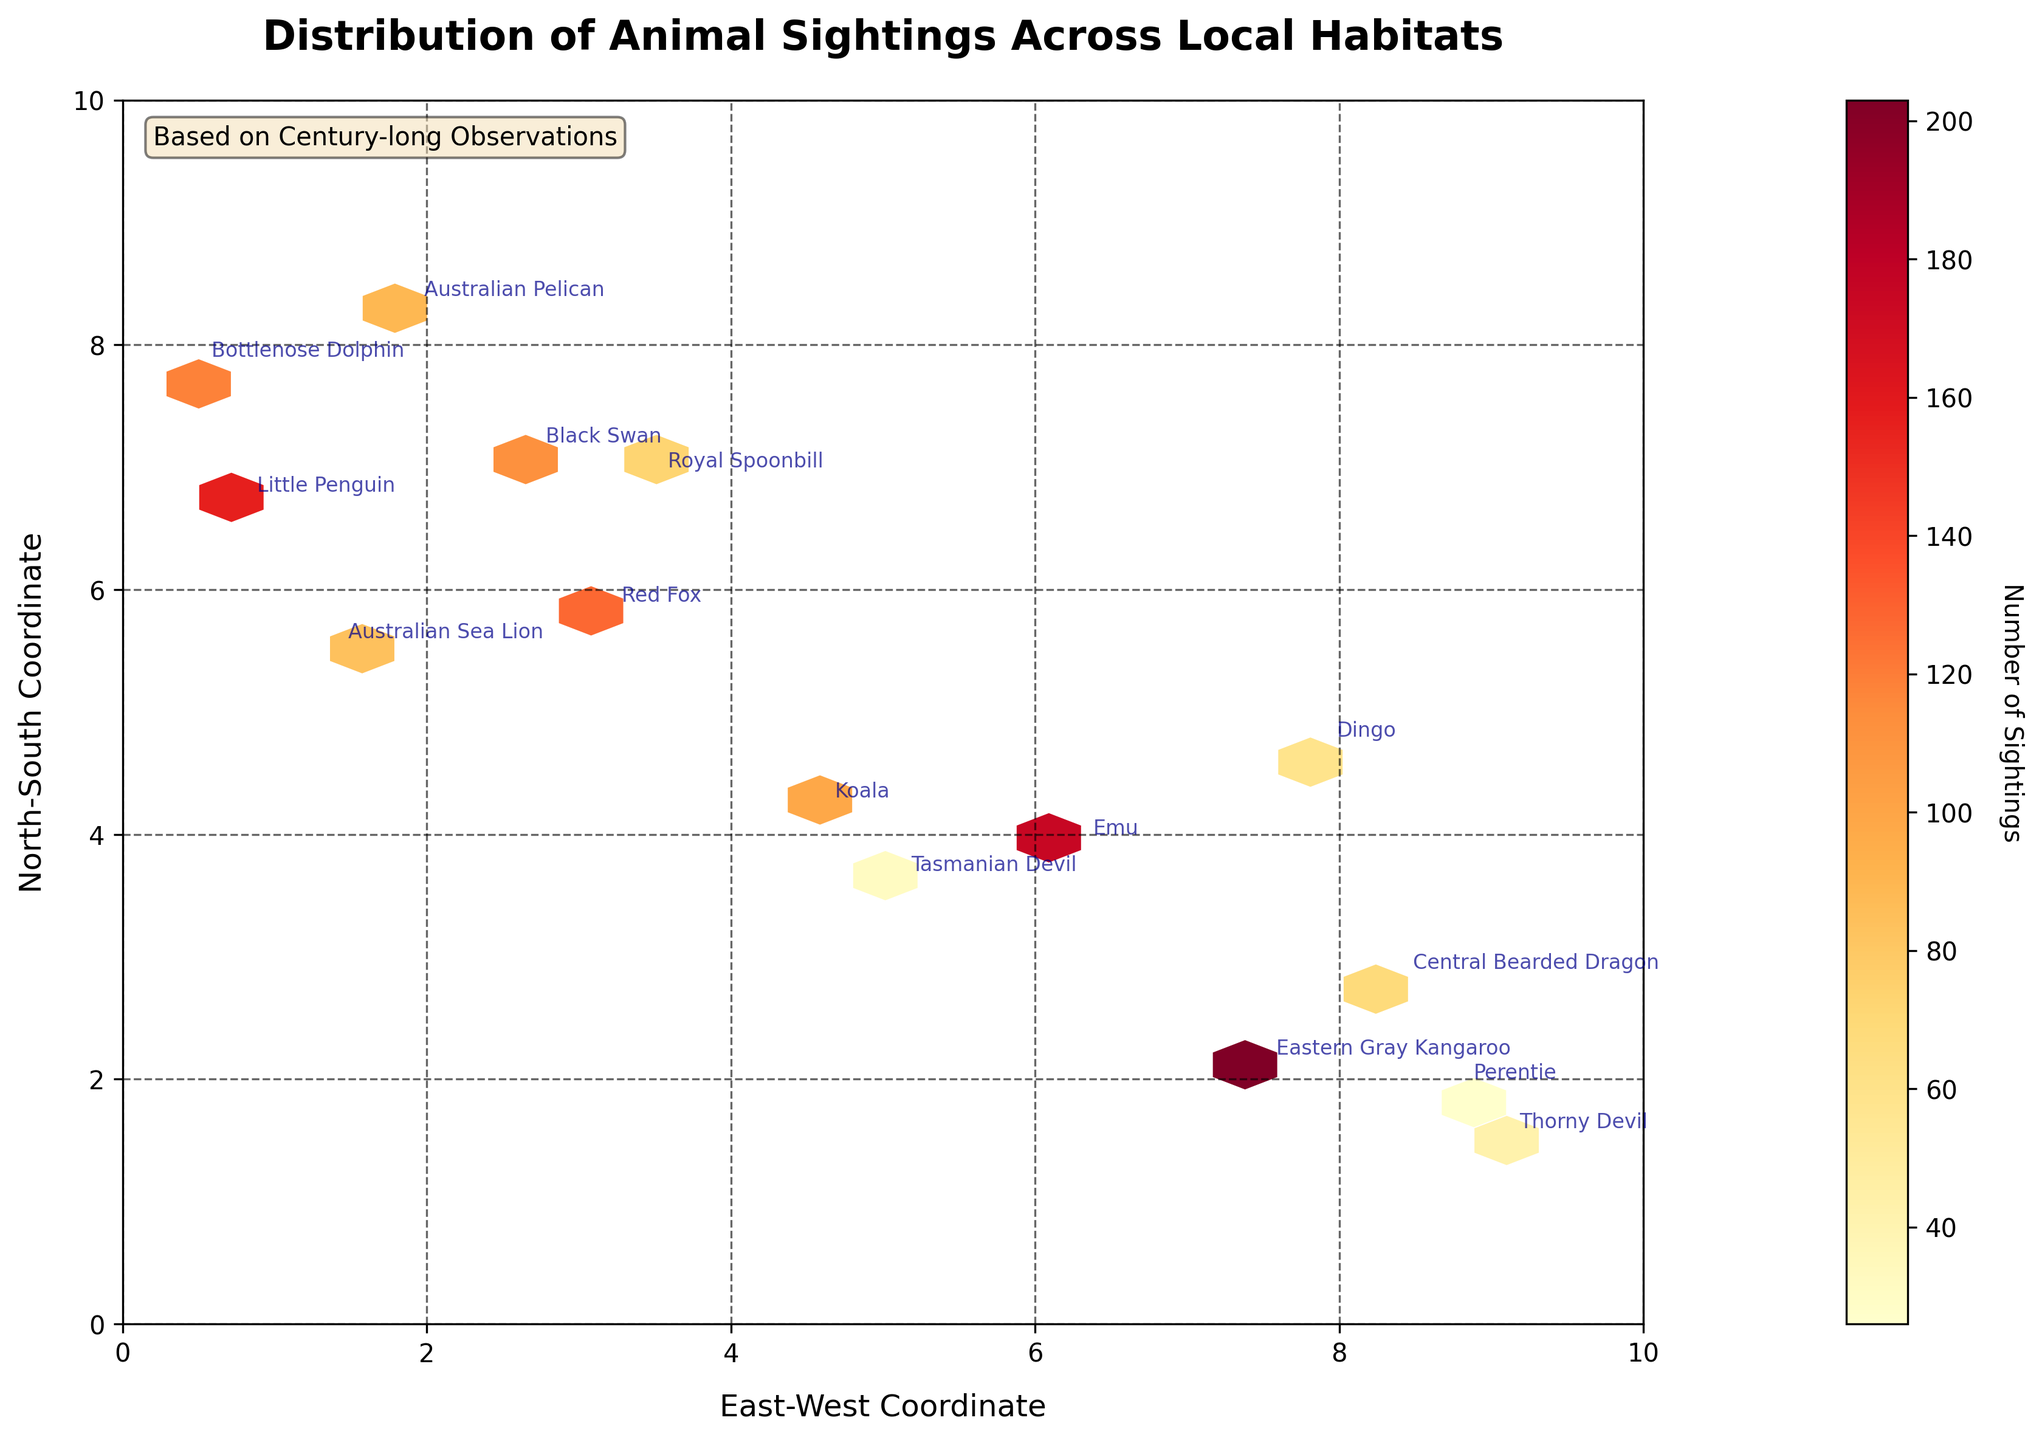What's the title of the figure? The title is located at the top of the figure, and it reads "Distribution of Animal Sightings Across Local Habitats."
Answer: Distribution of Animal Sightings Across Local Habitats Which habitat has the highest number of animal sightings? By looking at the color gradient in the hexbin plot, the darkest hexagons indicate the highest number of sightings. The Grassland habitat has the highest number of sightings, as seen around coordinates (7.5, 2.1).
Answer: Grassland What is the range of the x-coordinates? The x-axis represents the East-West Coordinate and is labeled with values ranging from 0 to 10.
Answer: 0 to 10 How many animals are sighted in the Forest habitat? Add all sightings of species in the Forest. From the data points, the sightings in the Forest are Red Fox (127), Koala (98), and Tasmanian Devil (31). Summing these gives 127 + 98 + 31 = 256.
Answer: 256 How do sightings in the Wetland compare to those in the Desert? Which one is higher? Summing up the sightings for the Wetland (Australian Pelican: 89, Black Swan: 112, Royal Spoonbill: 73) gives 274. For the Desert (Thorny Devil: 42, Central Bearded Dragon: 68, Perentie: 26), the total is 136. Comparing the two, Wetland has higher sightings.
Answer: Wetland Which species is located at the coordinates (0.8, 6.7)? By looking at the annotated species on the figure near the coordinates (0.8, 6.7), we can see that the species is the Little Penguin.
Answer: Little Penguin What's the most frequently sighted species in the Coastal habitat? From the data points for the Coastal habitat, the Little Penguin (156 sightings) is the species with the highest number of sightings.
Answer: Little Penguin Considering coordinates (4.6, 4.2) and (1.4, 5.5), which species is found farther east? The x-coordinates help us determine the eastward position. The coordinate (4.6, 4.2) corresponds to Koala, while (1.4, 5.5) corresponds to Australian Sea Lion. Koala is farther east with an x-coordinate of 4.6 compared to 1.4.
Answer: Koala Are there any species sighted in the coordinates x < 1.0 and y > 5.5? If so, which ones? Looking at the coordinates provided and the plot, the species in the Coastal habitat at (0.8, 6.7) is the Little Penguin, and at (0.5, 7.8) is the Bottlenose Dolphin. Both meet the criteria x < 1.0 and y > 5.5.
Answer: Little Penguin, Bottlenose Dolphin 